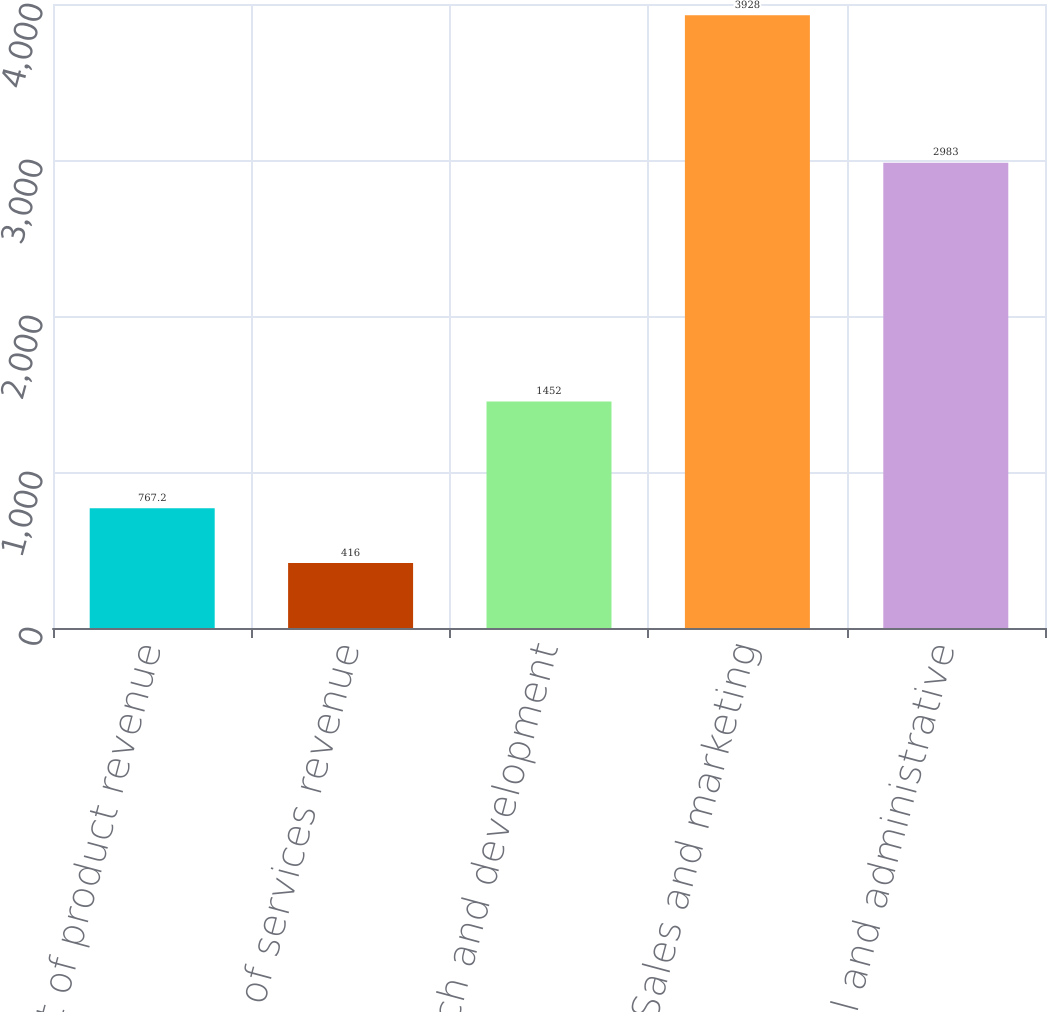Convert chart to OTSL. <chart><loc_0><loc_0><loc_500><loc_500><bar_chart><fcel>Cost of product revenue<fcel>Cost of services revenue<fcel>Research and development<fcel>Sales and marketing<fcel>General and administrative<nl><fcel>767.2<fcel>416<fcel>1452<fcel>3928<fcel>2983<nl></chart> 